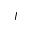<formula> <loc_0><loc_0><loc_500><loc_500>I</formula> 